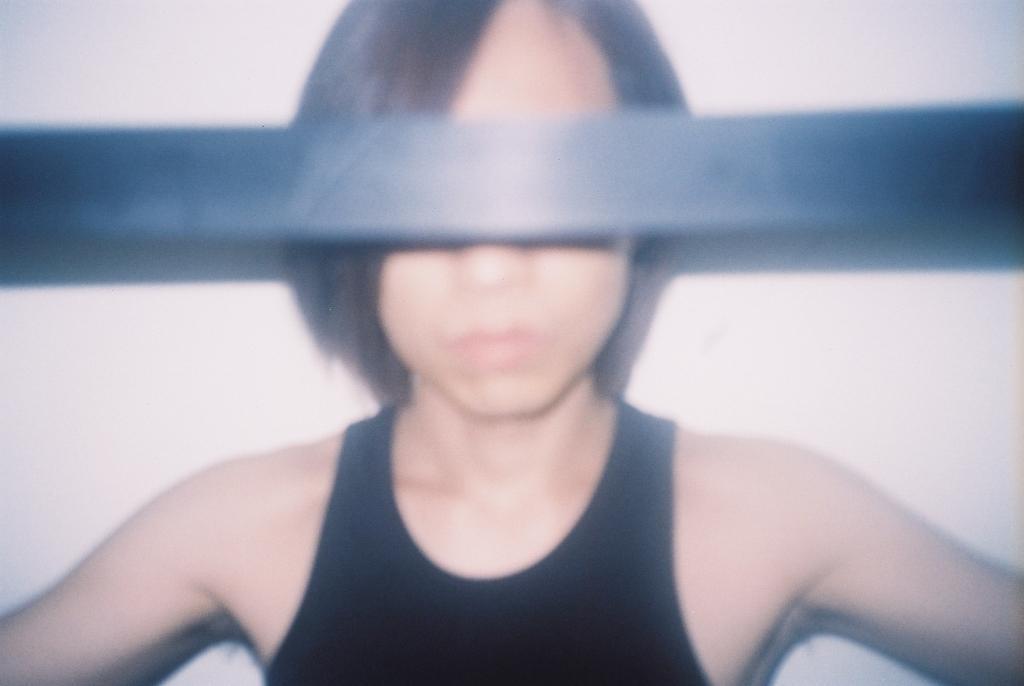Describe this image in one or two sentences. There is one woman wearing a black color top as we can see in the middle of this image. There is a black color cloth present at the top of this image, and there is a wall in the background. 